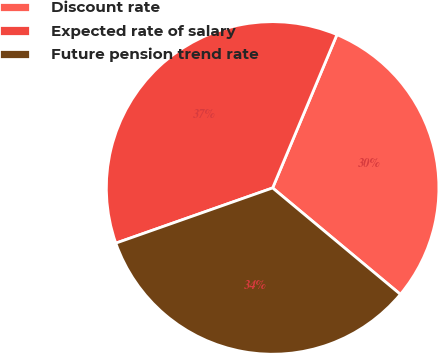<chart> <loc_0><loc_0><loc_500><loc_500><pie_chart><fcel>Discount rate<fcel>Expected rate of salary<fcel>Future pension trend rate<nl><fcel>29.73%<fcel>36.71%<fcel>33.56%<nl></chart> 